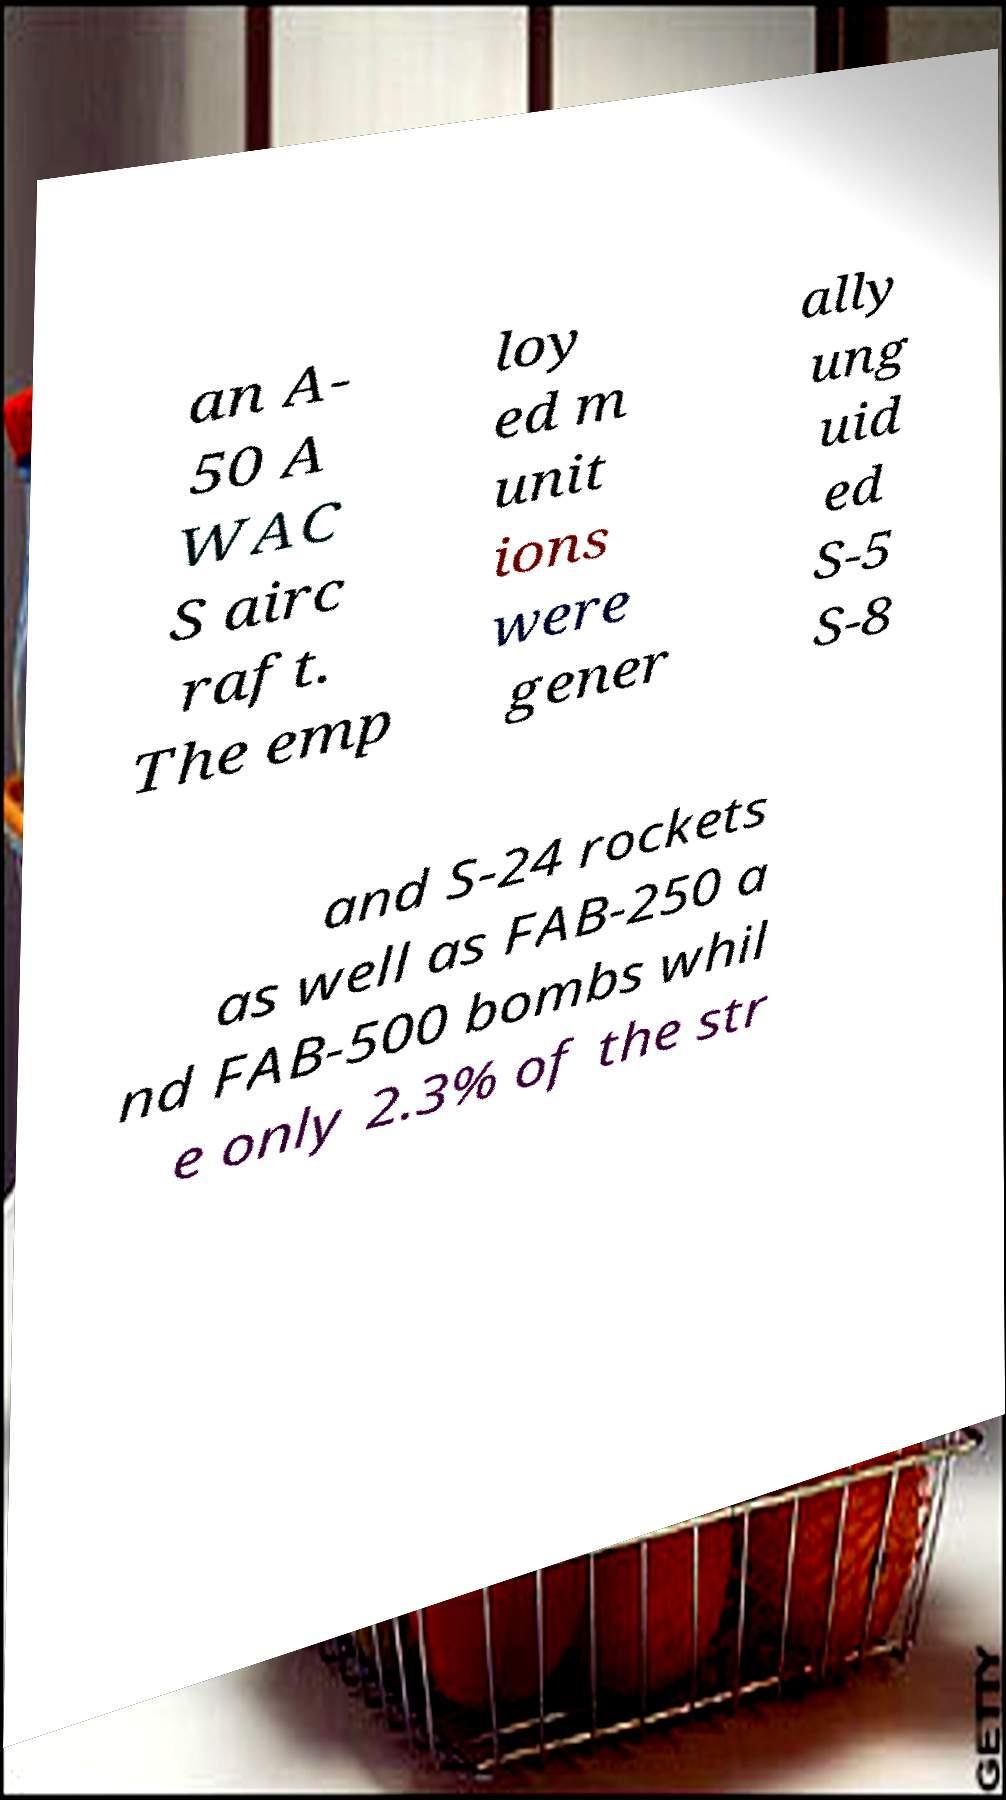Could you assist in decoding the text presented in this image and type it out clearly? an A- 50 A WAC S airc raft. The emp loy ed m unit ions were gener ally ung uid ed S-5 S-8 and S-24 rockets as well as FAB-250 a nd FAB-500 bombs whil e only 2.3% of the str 